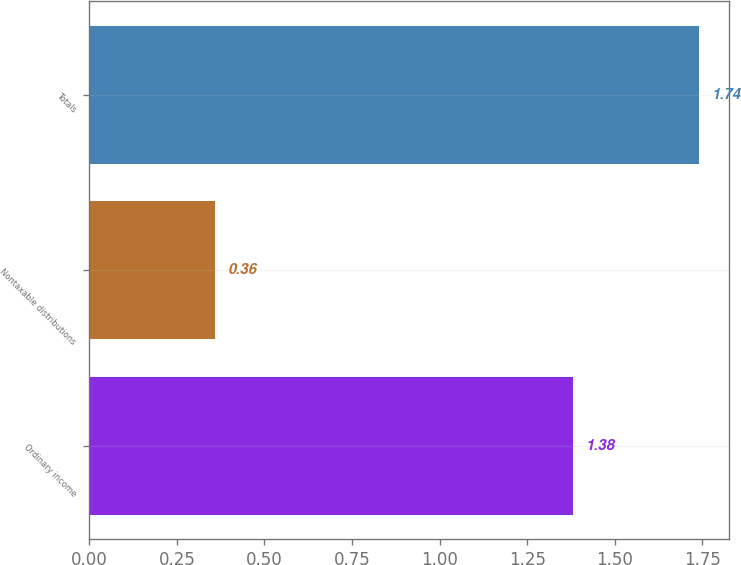Convert chart to OTSL. <chart><loc_0><loc_0><loc_500><loc_500><bar_chart><fcel>Ordinary income<fcel>Nontaxable distributions<fcel>Totals<nl><fcel>1.38<fcel>0.36<fcel>1.74<nl></chart> 